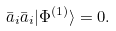Convert formula to latex. <formula><loc_0><loc_0><loc_500><loc_500>\bar { a } _ { i } \bar { a } _ { i } | \Phi ^ { ( 1 ) } \rangle = 0 .</formula> 